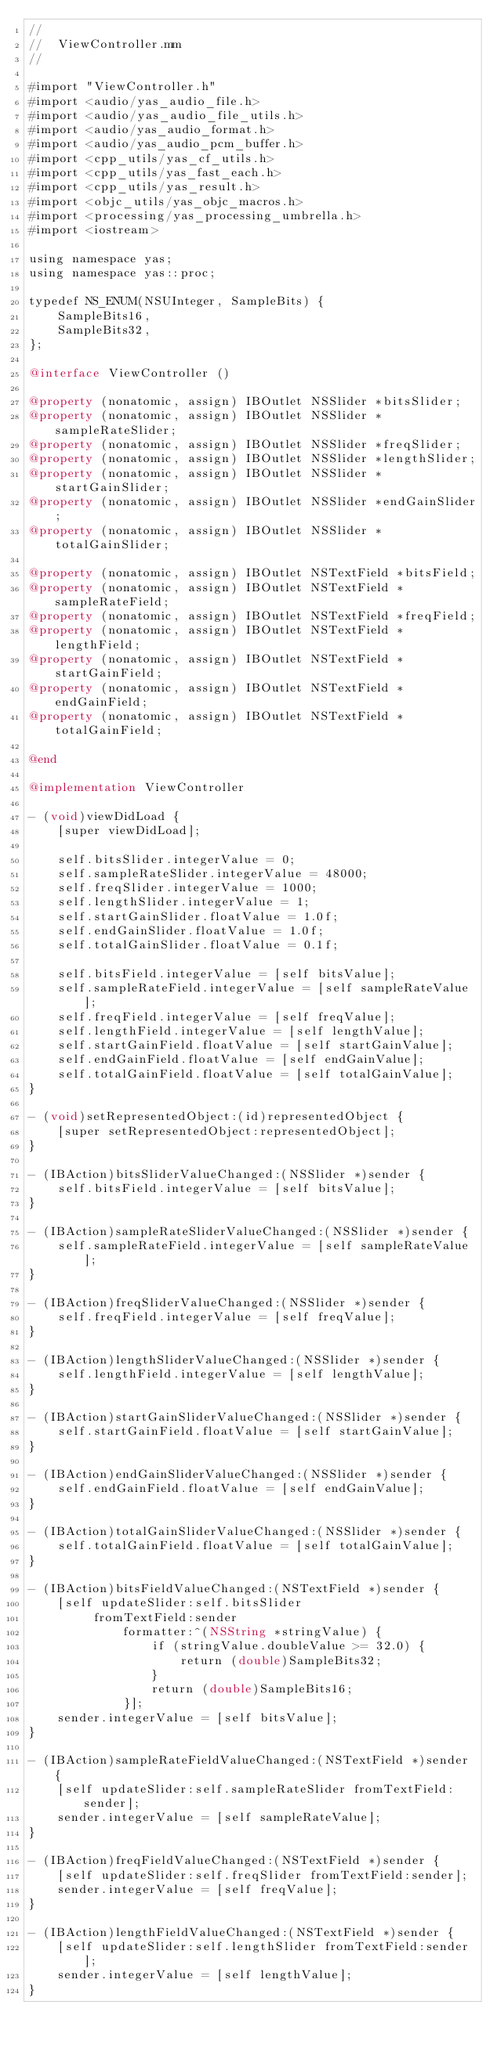Convert code to text. <code><loc_0><loc_0><loc_500><loc_500><_ObjectiveC_>//
//  ViewController.mm
//

#import "ViewController.h"
#import <audio/yas_audio_file.h>
#import <audio/yas_audio_file_utils.h>
#import <audio/yas_audio_format.h>
#import <audio/yas_audio_pcm_buffer.h>
#import <cpp_utils/yas_cf_utils.h>
#import <cpp_utils/yas_fast_each.h>
#import <cpp_utils/yas_result.h>
#import <objc_utils/yas_objc_macros.h>
#import <processing/yas_processing_umbrella.h>
#import <iostream>

using namespace yas;
using namespace yas::proc;

typedef NS_ENUM(NSUInteger, SampleBits) {
    SampleBits16,
    SampleBits32,
};

@interface ViewController ()

@property (nonatomic, assign) IBOutlet NSSlider *bitsSlider;
@property (nonatomic, assign) IBOutlet NSSlider *sampleRateSlider;
@property (nonatomic, assign) IBOutlet NSSlider *freqSlider;
@property (nonatomic, assign) IBOutlet NSSlider *lengthSlider;
@property (nonatomic, assign) IBOutlet NSSlider *startGainSlider;
@property (nonatomic, assign) IBOutlet NSSlider *endGainSlider;
@property (nonatomic, assign) IBOutlet NSSlider *totalGainSlider;

@property (nonatomic, assign) IBOutlet NSTextField *bitsField;
@property (nonatomic, assign) IBOutlet NSTextField *sampleRateField;
@property (nonatomic, assign) IBOutlet NSTextField *freqField;
@property (nonatomic, assign) IBOutlet NSTextField *lengthField;
@property (nonatomic, assign) IBOutlet NSTextField *startGainField;
@property (nonatomic, assign) IBOutlet NSTextField *endGainField;
@property (nonatomic, assign) IBOutlet NSTextField *totalGainField;

@end

@implementation ViewController

- (void)viewDidLoad {
    [super viewDidLoad];

    self.bitsSlider.integerValue = 0;
    self.sampleRateSlider.integerValue = 48000;
    self.freqSlider.integerValue = 1000;
    self.lengthSlider.integerValue = 1;
    self.startGainSlider.floatValue = 1.0f;
    self.endGainSlider.floatValue = 1.0f;
    self.totalGainSlider.floatValue = 0.1f;

    self.bitsField.integerValue = [self bitsValue];
    self.sampleRateField.integerValue = [self sampleRateValue];
    self.freqField.integerValue = [self freqValue];
    self.lengthField.integerValue = [self lengthValue];
    self.startGainField.floatValue = [self startGainValue];
    self.endGainField.floatValue = [self endGainValue];
    self.totalGainField.floatValue = [self totalGainValue];
}

- (void)setRepresentedObject:(id)representedObject {
    [super setRepresentedObject:representedObject];
}

- (IBAction)bitsSliderValueChanged:(NSSlider *)sender {
    self.bitsField.integerValue = [self bitsValue];
}

- (IBAction)sampleRateSliderValueChanged:(NSSlider *)sender {
    self.sampleRateField.integerValue = [self sampleRateValue];
}

- (IBAction)freqSliderValueChanged:(NSSlider *)sender {
    self.freqField.integerValue = [self freqValue];
}

- (IBAction)lengthSliderValueChanged:(NSSlider *)sender {
    self.lengthField.integerValue = [self lengthValue];
}

- (IBAction)startGainSliderValueChanged:(NSSlider *)sender {
    self.startGainField.floatValue = [self startGainValue];
}

- (IBAction)endGainSliderValueChanged:(NSSlider *)sender {
    self.endGainField.floatValue = [self endGainValue];
}

- (IBAction)totalGainSliderValueChanged:(NSSlider *)sender {
    self.totalGainField.floatValue = [self totalGainValue];
}

- (IBAction)bitsFieldValueChanged:(NSTextField *)sender {
    [self updateSlider:self.bitsSlider
         fromTextField:sender
             formatter:^(NSString *stringValue) {
                 if (stringValue.doubleValue >= 32.0) {
                     return (double)SampleBits32;
                 }
                 return (double)SampleBits16;
             }];
    sender.integerValue = [self bitsValue];
}

- (IBAction)sampleRateFieldValueChanged:(NSTextField *)sender {
    [self updateSlider:self.sampleRateSlider fromTextField:sender];
    sender.integerValue = [self sampleRateValue];
}

- (IBAction)freqFieldValueChanged:(NSTextField *)sender {
    [self updateSlider:self.freqSlider fromTextField:sender];
    sender.integerValue = [self freqValue];
}

- (IBAction)lengthFieldValueChanged:(NSTextField *)sender {
    [self updateSlider:self.lengthSlider fromTextField:sender];
    sender.integerValue = [self lengthValue];
}
</code> 